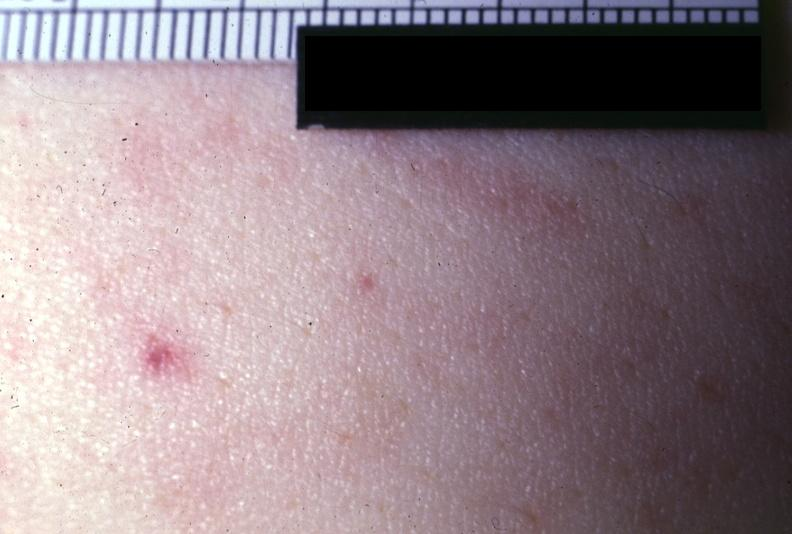what does this image show?
Answer the question using a single word or phrase. Close-up photo very good 